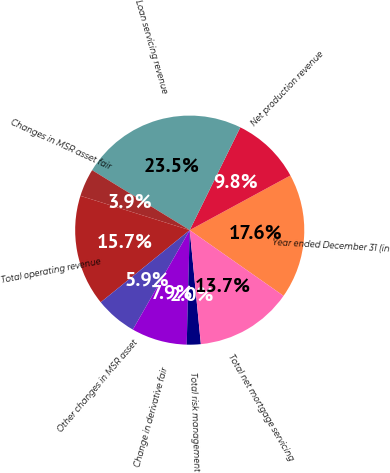<chart> <loc_0><loc_0><loc_500><loc_500><pie_chart><fcel>Year ended December 31 (in<fcel>Net production revenue<fcel>Loan servicing revenue<fcel>Changes in MSR asset fair<fcel>Total operating revenue<fcel>Other changes in MSR asset<fcel>Change in derivative fair<fcel>Total risk management<fcel>Total net mortgage servicing<nl><fcel>17.64%<fcel>9.81%<fcel>23.51%<fcel>3.93%<fcel>15.68%<fcel>5.89%<fcel>7.85%<fcel>1.97%<fcel>13.72%<nl></chart> 